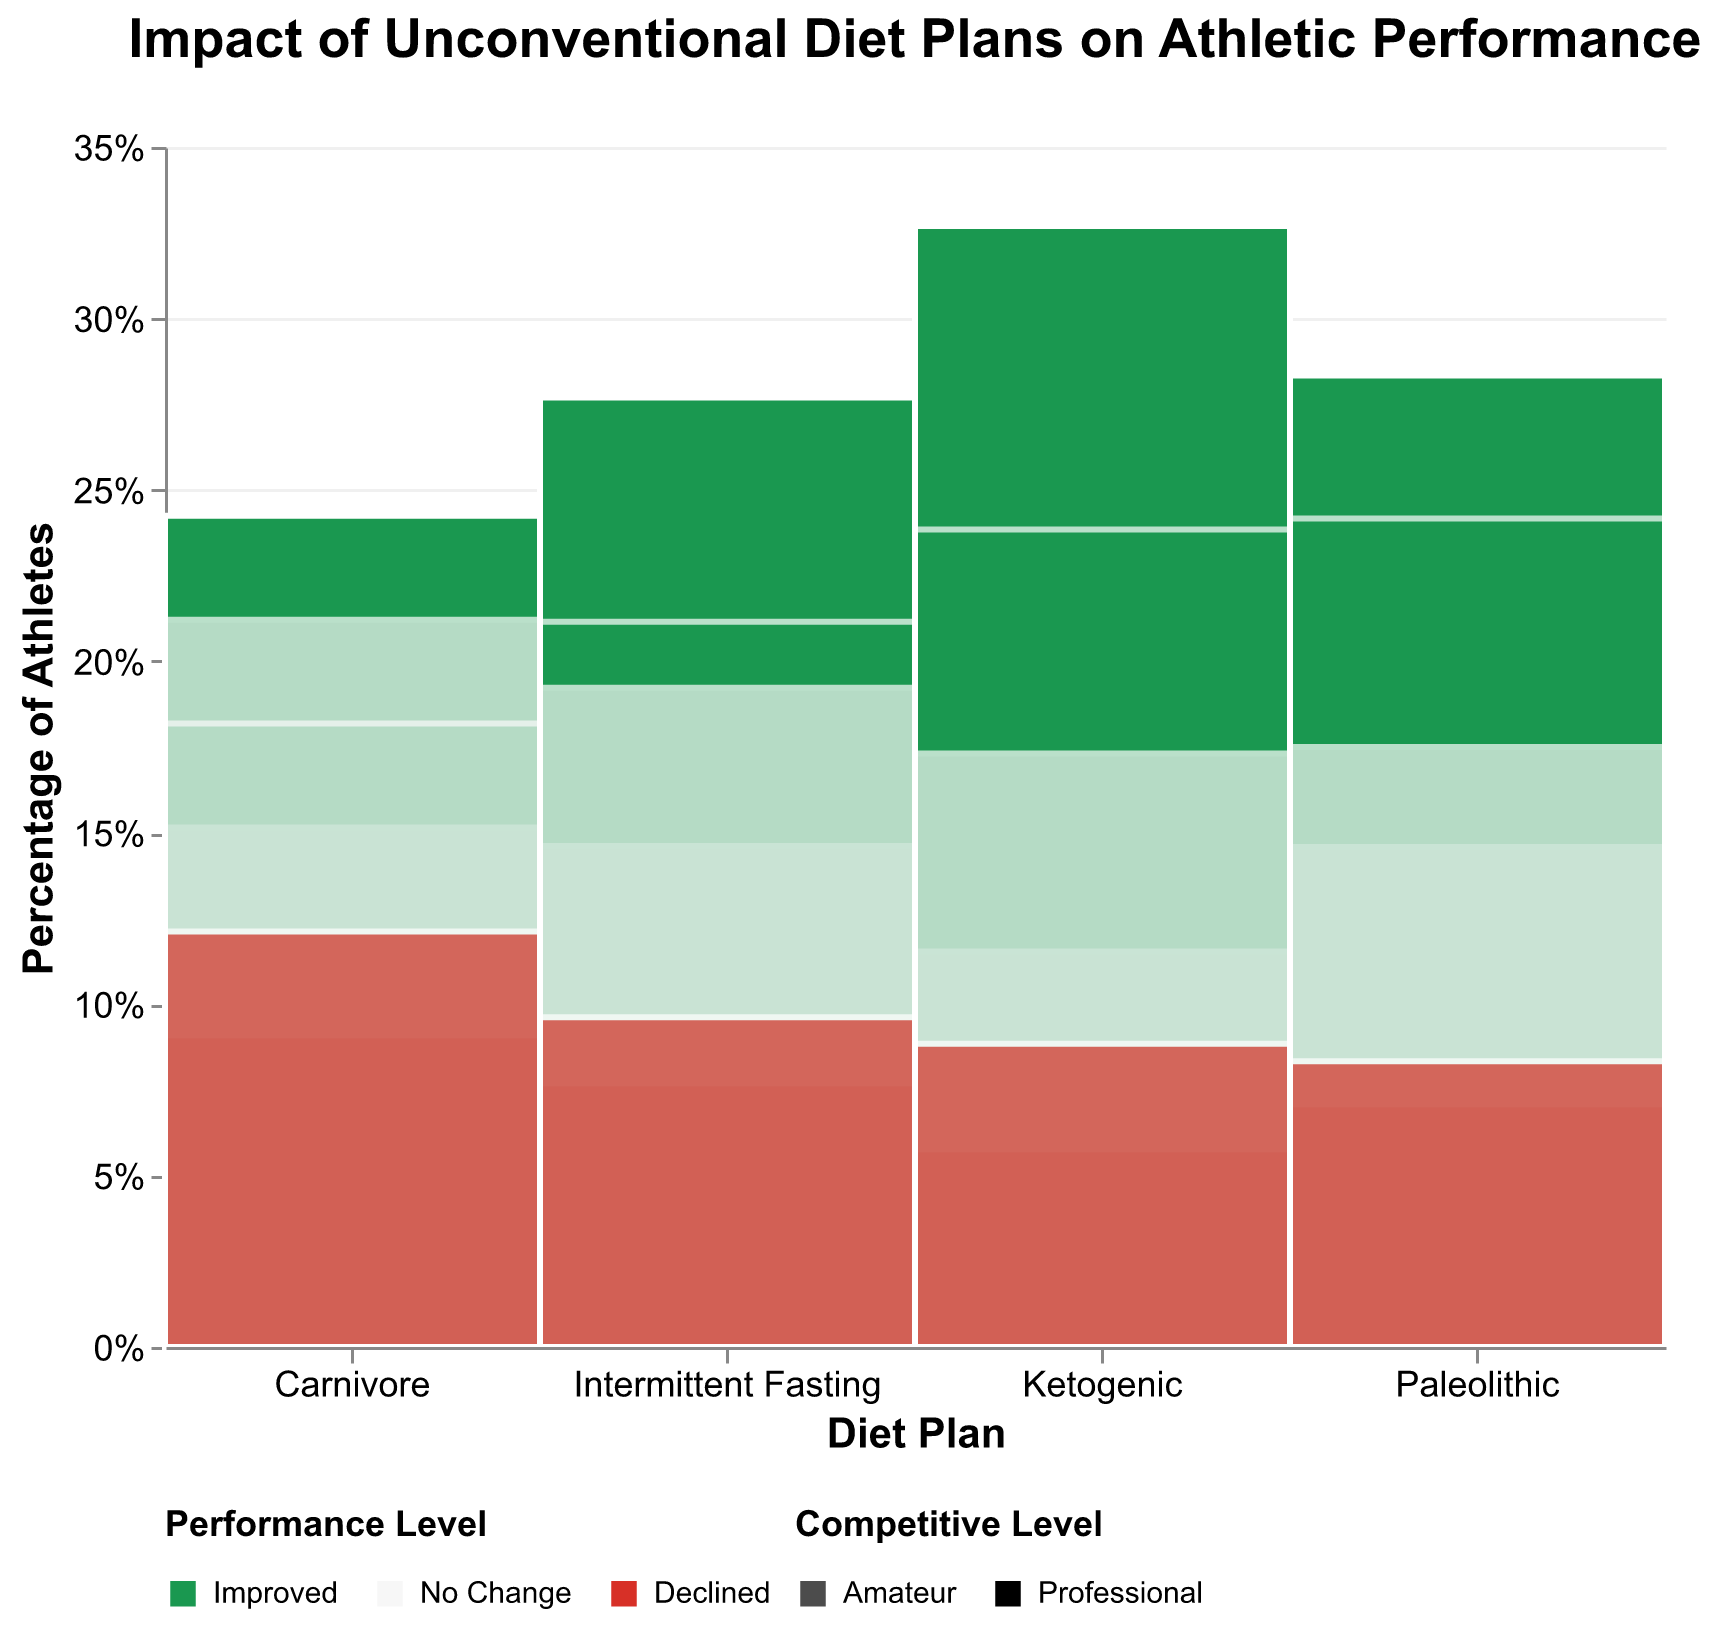What is the title of the figure? The title is usually displayed at the top of the figure. Here, it reads "Impact of Unconventional Diet Plans on Athletic Performance".
Answer: Impact of Unconventional Diet Plans on Athletic Performance Which diet plan has the highest percentage of athletes who saw an improvement in their performance at the professional level? To find the highest percentage of improvement at the professional level, look for the diet plan segment with the largest improved performance bar that has the higher opacity (indicating professional level).
Answer: Ketogenic What percentage of professional athletes on the Paleolithic diet saw no change in their performance? Look for the Paleolithic diet bar with "No Change" category and higher opacity, and check the tooltip or the percentage on the y-axis if available.
Answer: 20% How do the percentages of amateur athletes who saw improvement compare between the Ketogenic and Intermittent Fasting diets? Check the bars for Ketogenic and Intermittent Fasting under the "Amateur" competitive level, specifically their improvement segments, and compare their heights or percentages displayed in the figure.
Answer: Ketogenic is higher Which diet plan has the lowest percentage of athletes experiencing declined performance at the amateur level? Identify the diet plan with the smallest "Declined" segment within the amateur opacity level by comparing the heights or percentages of the segmented bars.
Answer: Paleolithic In the context of professional athletes, which diet plan shows the largest difference between the improved and declined performance levels? Calculate the difference by comparing the heights/percentages of the "Improved" and "Declined" segments for each diet plan under the professional opacity.
Answer: Ketogenic What overall pattern can be observed about the impact of the Paleolithic diet compared to the other diets in terms of improving performance across both competitive levels? Look for the heights/percentages of the "Improved" segments across both professional and amateur levels and compare them with other diet plans to identify a pattern of improvement.
Answer: Generally higher improvement Which diet plan shows nearly equal percentages of professional athletes who saw improvement and those who saw no change? Look for the diet plan under the professional opacity level that has almost equal heights/percentages for the "Improved" and "No Change" segments.
Answer: Intermittent Fasting What is the proportion of amateur athletes on the Carnivore diet who experienced no change in performance relative to those who saw improvement? By comparing the heights or percentages of the "No Change" and "Improved" segments under the amateur opacity for the Carnivore diet, calculate the relative proportion.
Answer: Similar 